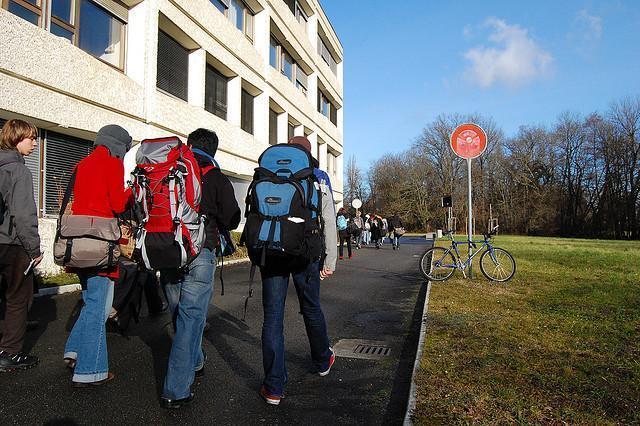How many people can you see?
Give a very brief answer. 4. How many bicycles are there?
Give a very brief answer. 1. How many backpacks are there?
Give a very brief answer. 2. 